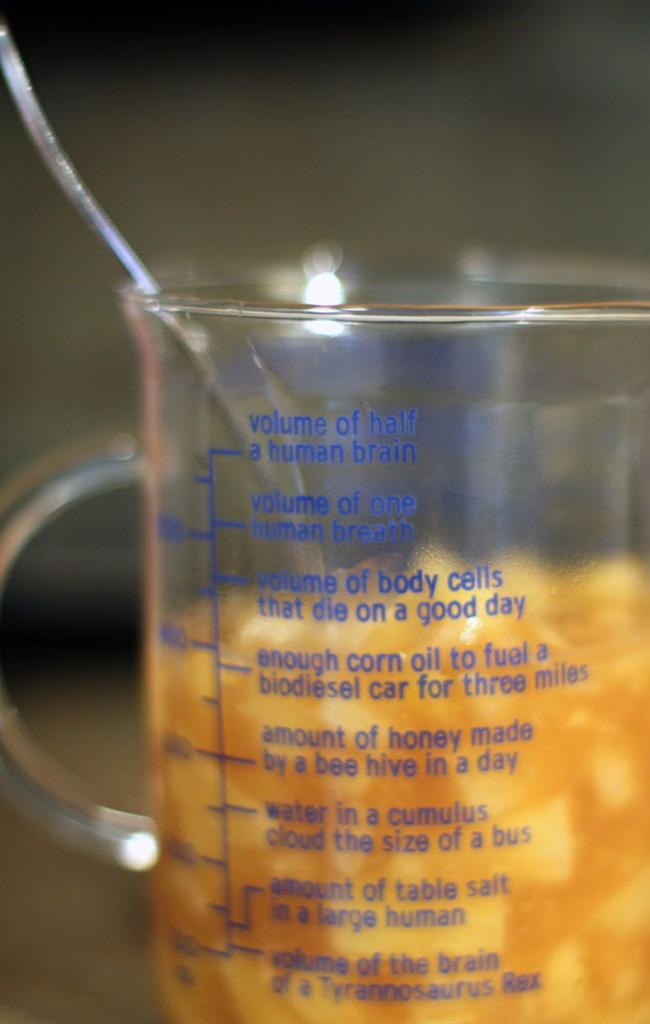<image>
Relay a brief, clear account of the picture shown. a measuring cup with words like Volume of Half a Human Brain 